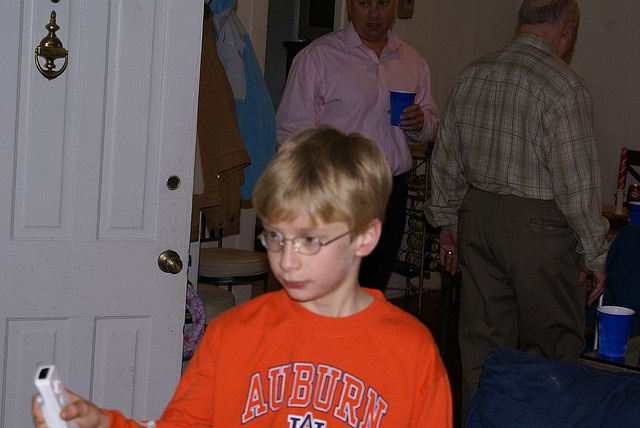Describe the objects in this image and their specific colors. I can see people in gray, red, brown, and black tones, people in gray and black tones, people in gray, purple, black, and maroon tones, chair in gray and black tones, and people in black and gray tones in this image. 